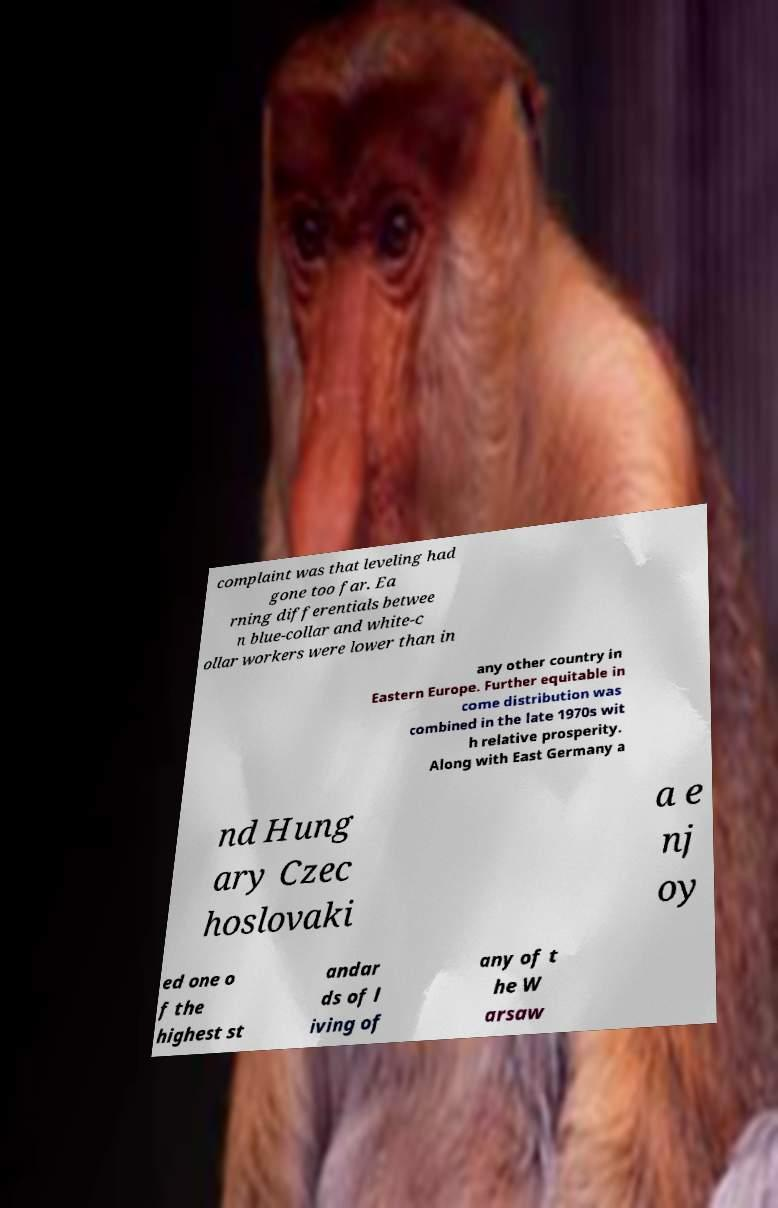Please identify and transcribe the text found in this image. complaint was that leveling had gone too far. Ea rning differentials betwee n blue-collar and white-c ollar workers were lower than in any other country in Eastern Europe. Further equitable in come distribution was combined in the late 1970s wit h relative prosperity. Along with East Germany a nd Hung ary Czec hoslovaki a e nj oy ed one o f the highest st andar ds of l iving of any of t he W arsaw 